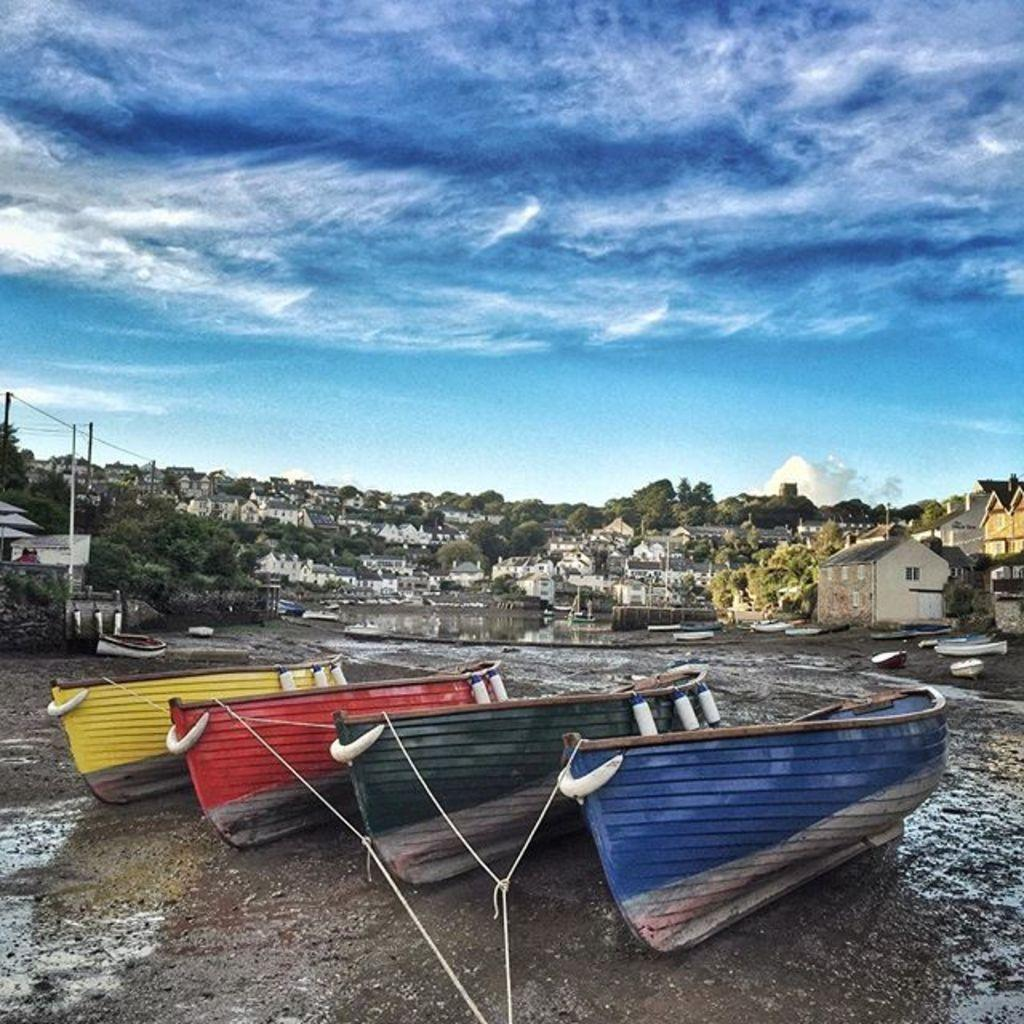What is unusual about the location of the boats in the image? The boats are on land in the image, which is not their typical location. What can be seen in the distance behind the boats? There are houses, trees, and the sky visible in the background of the image. What type of game is being played by the doll in the image? There is no doll or game present in the image. 